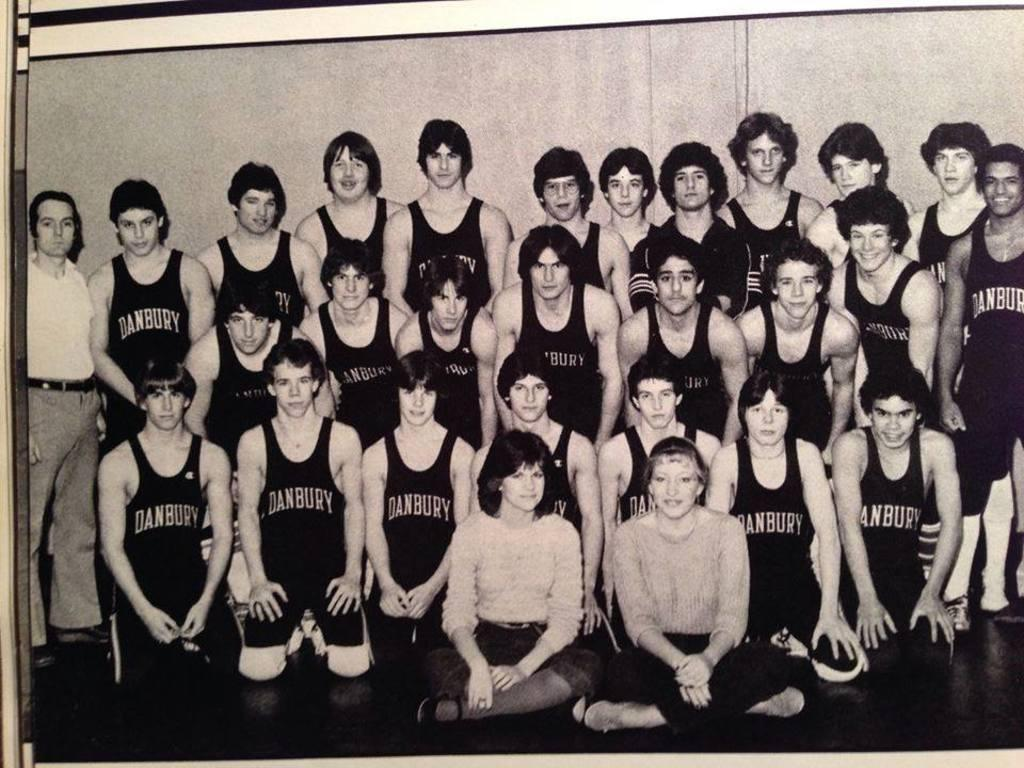<image>
Relay a brief, clear account of the picture shown. The DANBURY basketball team gathered to have their picture taken in black and white. 